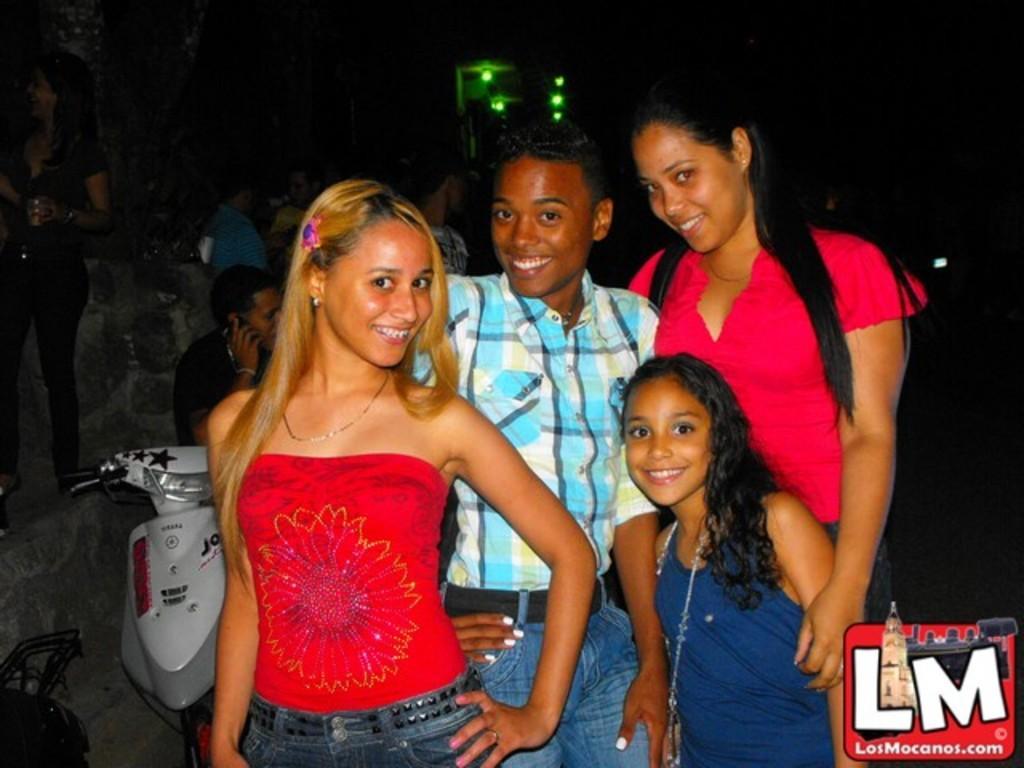Describe this image in one or two sentences. In this image I can see four people standing and posing for the picture. I can see other people behind them. I can see a bike on the left hand side of the image. In the bottom right corner, I can see some text. The background is dark. 